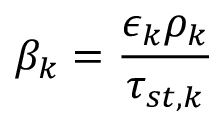<formula> <loc_0><loc_0><loc_500><loc_500>\beta _ { k } = \frac { \epsilon _ { k } \rho _ { k } } { \tau _ { s t , k } }</formula> 